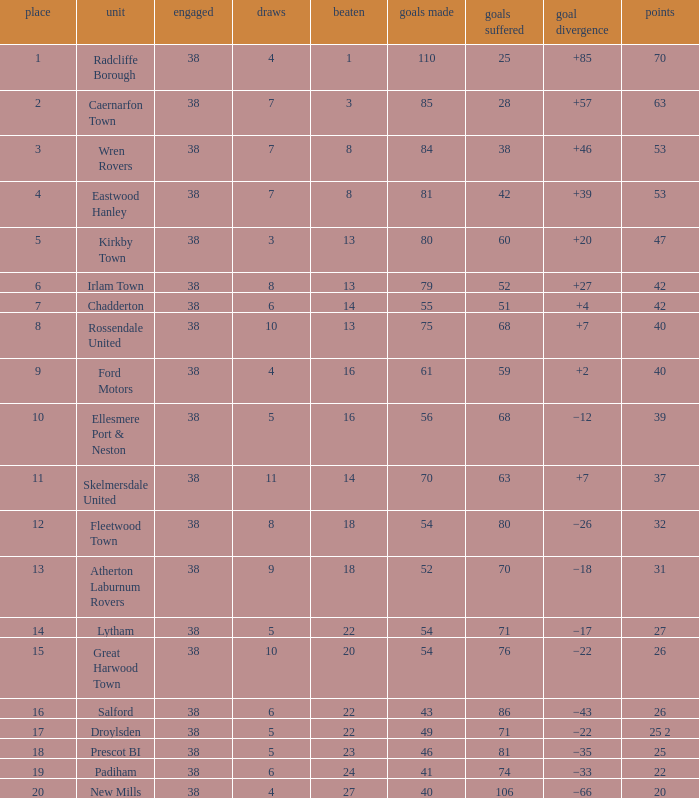How much Drawn has Goals Against of 81, and a Lost larger than 23? 0.0. 